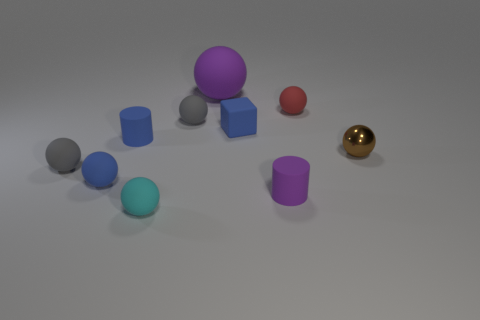Subtract all brown spheres. How many spheres are left? 6 Subtract all red rubber spheres. How many spheres are left? 6 Subtract all purple spheres. Subtract all brown cylinders. How many spheres are left? 6 Subtract all spheres. How many objects are left? 3 Subtract 0 red blocks. How many objects are left? 10 Subtract all tiny cyan spheres. Subtract all small spheres. How many objects are left? 3 Add 4 small spheres. How many small spheres are left? 10 Add 4 shiny spheres. How many shiny spheres exist? 5 